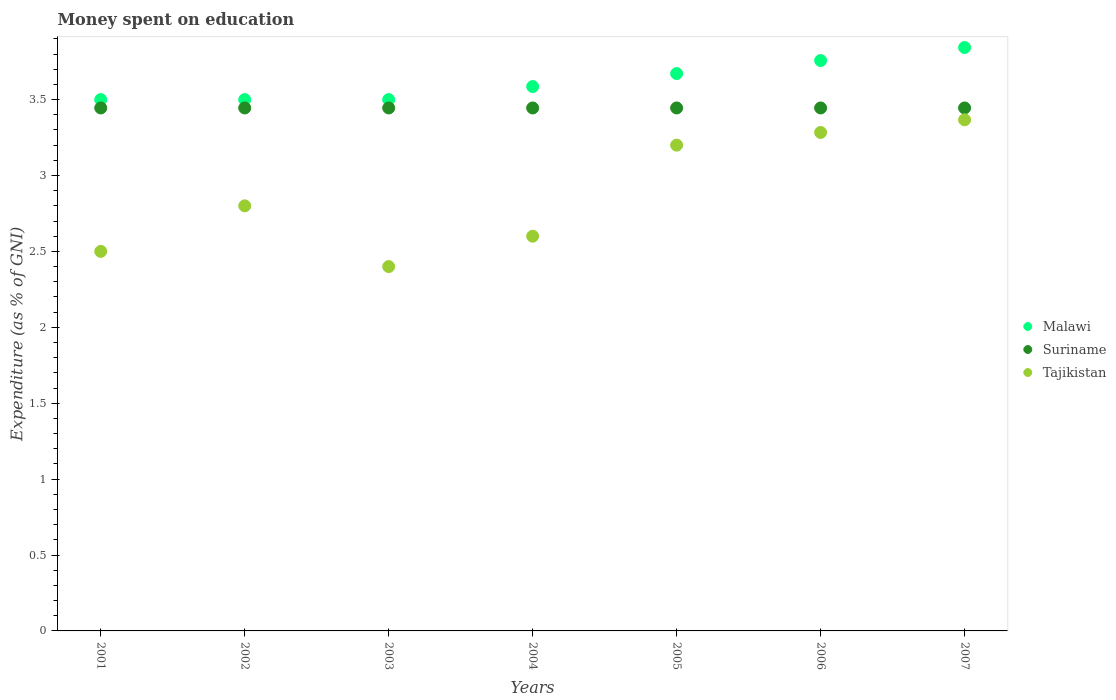How many different coloured dotlines are there?
Keep it short and to the point. 3. Is the number of dotlines equal to the number of legend labels?
Provide a short and direct response. Yes. Across all years, what is the maximum amount of money spent on education in Tajikistan?
Offer a terse response. 3.37. In which year was the amount of money spent on education in Suriname maximum?
Your answer should be very brief. 2001. What is the total amount of money spent on education in Suriname in the graph?
Your response must be concise. 24.11. What is the difference between the amount of money spent on education in Tajikistan in 2002 and that in 2004?
Keep it short and to the point. 0.2. What is the difference between the amount of money spent on education in Malawi in 2001 and the amount of money spent on education in Suriname in 2007?
Provide a succinct answer. 0.06. What is the average amount of money spent on education in Malawi per year?
Ensure brevity in your answer.  3.62. In the year 2005, what is the difference between the amount of money spent on education in Malawi and amount of money spent on education in Suriname?
Offer a very short reply. 0.23. In how many years, is the amount of money spent on education in Suriname greater than 3.1 %?
Offer a very short reply. 7. What is the ratio of the amount of money spent on education in Suriname in 2003 to that in 2004?
Your response must be concise. 1. What is the difference between the highest and the second highest amount of money spent on education in Malawi?
Ensure brevity in your answer.  0.09. Is the sum of the amount of money spent on education in Suriname in 2001 and 2003 greater than the maximum amount of money spent on education in Malawi across all years?
Give a very brief answer. Yes. Is it the case that in every year, the sum of the amount of money spent on education in Tajikistan and amount of money spent on education in Suriname  is greater than the amount of money spent on education in Malawi?
Ensure brevity in your answer.  Yes. Does the amount of money spent on education in Suriname monotonically increase over the years?
Your answer should be very brief. No. Is the amount of money spent on education in Suriname strictly greater than the amount of money spent on education in Malawi over the years?
Offer a very short reply. No. Is the amount of money spent on education in Malawi strictly less than the amount of money spent on education in Suriname over the years?
Make the answer very short. No. How many dotlines are there?
Give a very brief answer. 3. Does the graph contain any zero values?
Your answer should be very brief. No. Where does the legend appear in the graph?
Make the answer very short. Center right. How are the legend labels stacked?
Give a very brief answer. Vertical. What is the title of the graph?
Give a very brief answer. Money spent on education. Does "Mauritius" appear as one of the legend labels in the graph?
Offer a terse response. No. What is the label or title of the Y-axis?
Your answer should be compact. Expenditure (as % of GNI). What is the Expenditure (as % of GNI) in Suriname in 2001?
Your answer should be very brief. 3.44. What is the Expenditure (as % of GNI) of Tajikistan in 2001?
Make the answer very short. 2.5. What is the Expenditure (as % of GNI) of Suriname in 2002?
Keep it short and to the point. 3.44. What is the Expenditure (as % of GNI) in Malawi in 2003?
Offer a terse response. 3.5. What is the Expenditure (as % of GNI) of Suriname in 2003?
Provide a short and direct response. 3.44. What is the Expenditure (as % of GNI) of Tajikistan in 2003?
Ensure brevity in your answer.  2.4. What is the Expenditure (as % of GNI) in Malawi in 2004?
Your answer should be compact. 3.59. What is the Expenditure (as % of GNI) of Suriname in 2004?
Provide a succinct answer. 3.44. What is the Expenditure (as % of GNI) of Malawi in 2005?
Your answer should be very brief. 3.67. What is the Expenditure (as % of GNI) of Suriname in 2005?
Your answer should be compact. 3.44. What is the Expenditure (as % of GNI) of Tajikistan in 2005?
Your response must be concise. 3.2. What is the Expenditure (as % of GNI) of Malawi in 2006?
Give a very brief answer. 3.76. What is the Expenditure (as % of GNI) in Suriname in 2006?
Offer a very short reply. 3.44. What is the Expenditure (as % of GNI) of Tajikistan in 2006?
Offer a very short reply. 3.28. What is the Expenditure (as % of GNI) in Malawi in 2007?
Ensure brevity in your answer.  3.84. What is the Expenditure (as % of GNI) of Suriname in 2007?
Keep it short and to the point. 3.44. What is the Expenditure (as % of GNI) in Tajikistan in 2007?
Your answer should be compact. 3.37. Across all years, what is the maximum Expenditure (as % of GNI) of Malawi?
Your response must be concise. 3.84. Across all years, what is the maximum Expenditure (as % of GNI) of Suriname?
Provide a short and direct response. 3.44. Across all years, what is the maximum Expenditure (as % of GNI) of Tajikistan?
Make the answer very short. 3.37. Across all years, what is the minimum Expenditure (as % of GNI) in Suriname?
Your answer should be very brief. 3.44. What is the total Expenditure (as % of GNI) of Malawi in the graph?
Your answer should be very brief. 25.36. What is the total Expenditure (as % of GNI) of Suriname in the graph?
Provide a succinct answer. 24.11. What is the total Expenditure (as % of GNI) of Tajikistan in the graph?
Make the answer very short. 20.15. What is the difference between the Expenditure (as % of GNI) of Malawi in 2001 and that in 2002?
Offer a very short reply. 0. What is the difference between the Expenditure (as % of GNI) in Suriname in 2001 and that in 2002?
Provide a succinct answer. 0. What is the difference between the Expenditure (as % of GNI) in Malawi in 2001 and that in 2004?
Offer a terse response. -0.09. What is the difference between the Expenditure (as % of GNI) of Malawi in 2001 and that in 2005?
Provide a succinct answer. -0.17. What is the difference between the Expenditure (as % of GNI) of Suriname in 2001 and that in 2005?
Provide a short and direct response. 0. What is the difference between the Expenditure (as % of GNI) of Malawi in 2001 and that in 2006?
Offer a very short reply. -0.26. What is the difference between the Expenditure (as % of GNI) of Suriname in 2001 and that in 2006?
Provide a short and direct response. 0. What is the difference between the Expenditure (as % of GNI) in Tajikistan in 2001 and that in 2006?
Your answer should be very brief. -0.78. What is the difference between the Expenditure (as % of GNI) in Malawi in 2001 and that in 2007?
Your answer should be very brief. -0.34. What is the difference between the Expenditure (as % of GNI) of Suriname in 2001 and that in 2007?
Offer a terse response. 0. What is the difference between the Expenditure (as % of GNI) of Tajikistan in 2001 and that in 2007?
Ensure brevity in your answer.  -0.87. What is the difference between the Expenditure (as % of GNI) of Malawi in 2002 and that in 2003?
Provide a succinct answer. 0. What is the difference between the Expenditure (as % of GNI) of Suriname in 2002 and that in 2003?
Provide a succinct answer. 0. What is the difference between the Expenditure (as % of GNI) of Tajikistan in 2002 and that in 2003?
Provide a short and direct response. 0.4. What is the difference between the Expenditure (as % of GNI) in Malawi in 2002 and that in 2004?
Give a very brief answer. -0.09. What is the difference between the Expenditure (as % of GNI) in Suriname in 2002 and that in 2004?
Keep it short and to the point. 0. What is the difference between the Expenditure (as % of GNI) of Tajikistan in 2002 and that in 2004?
Offer a terse response. 0.2. What is the difference between the Expenditure (as % of GNI) in Malawi in 2002 and that in 2005?
Offer a terse response. -0.17. What is the difference between the Expenditure (as % of GNI) in Malawi in 2002 and that in 2006?
Ensure brevity in your answer.  -0.26. What is the difference between the Expenditure (as % of GNI) of Tajikistan in 2002 and that in 2006?
Provide a succinct answer. -0.48. What is the difference between the Expenditure (as % of GNI) in Malawi in 2002 and that in 2007?
Your answer should be very brief. -0.34. What is the difference between the Expenditure (as % of GNI) of Tajikistan in 2002 and that in 2007?
Offer a very short reply. -0.57. What is the difference between the Expenditure (as % of GNI) of Malawi in 2003 and that in 2004?
Give a very brief answer. -0.09. What is the difference between the Expenditure (as % of GNI) in Suriname in 2003 and that in 2004?
Give a very brief answer. 0. What is the difference between the Expenditure (as % of GNI) of Tajikistan in 2003 and that in 2004?
Provide a succinct answer. -0.2. What is the difference between the Expenditure (as % of GNI) of Malawi in 2003 and that in 2005?
Your response must be concise. -0.17. What is the difference between the Expenditure (as % of GNI) in Suriname in 2003 and that in 2005?
Give a very brief answer. 0. What is the difference between the Expenditure (as % of GNI) in Tajikistan in 2003 and that in 2005?
Provide a succinct answer. -0.8. What is the difference between the Expenditure (as % of GNI) in Malawi in 2003 and that in 2006?
Offer a very short reply. -0.26. What is the difference between the Expenditure (as % of GNI) of Suriname in 2003 and that in 2006?
Give a very brief answer. 0. What is the difference between the Expenditure (as % of GNI) of Tajikistan in 2003 and that in 2006?
Your answer should be very brief. -0.88. What is the difference between the Expenditure (as % of GNI) in Malawi in 2003 and that in 2007?
Give a very brief answer. -0.34. What is the difference between the Expenditure (as % of GNI) of Suriname in 2003 and that in 2007?
Give a very brief answer. 0. What is the difference between the Expenditure (as % of GNI) of Tajikistan in 2003 and that in 2007?
Offer a terse response. -0.97. What is the difference between the Expenditure (as % of GNI) of Malawi in 2004 and that in 2005?
Provide a short and direct response. -0.09. What is the difference between the Expenditure (as % of GNI) of Suriname in 2004 and that in 2005?
Provide a succinct answer. 0. What is the difference between the Expenditure (as % of GNI) of Malawi in 2004 and that in 2006?
Your response must be concise. -0.17. What is the difference between the Expenditure (as % of GNI) of Tajikistan in 2004 and that in 2006?
Ensure brevity in your answer.  -0.68. What is the difference between the Expenditure (as % of GNI) of Malawi in 2004 and that in 2007?
Give a very brief answer. -0.26. What is the difference between the Expenditure (as % of GNI) in Tajikistan in 2004 and that in 2007?
Your response must be concise. -0.77. What is the difference between the Expenditure (as % of GNI) in Malawi in 2005 and that in 2006?
Provide a short and direct response. -0.09. What is the difference between the Expenditure (as % of GNI) of Tajikistan in 2005 and that in 2006?
Provide a short and direct response. -0.08. What is the difference between the Expenditure (as % of GNI) of Malawi in 2005 and that in 2007?
Offer a very short reply. -0.17. What is the difference between the Expenditure (as % of GNI) in Suriname in 2005 and that in 2007?
Give a very brief answer. 0. What is the difference between the Expenditure (as % of GNI) of Tajikistan in 2005 and that in 2007?
Offer a terse response. -0.17. What is the difference between the Expenditure (as % of GNI) in Malawi in 2006 and that in 2007?
Keep it short and to the point. -0.09. What is the difference between the Expenditure (as % of GNI) of Tajikistan in 2006 and that in 2007?
Offer a very short reply. -0.08. What is the difference between the Expenditure (as % of GNI) in Malawi in 2001 and the Expenditure (as % of GNI) in Suriname in 2002?
Give a very brief answer. 0.06. What is the difference between the Expenditure (as % of GNI) of Suriname in 2001 and the Expenditure (as % of GNI) of Tajikistan in 2002?
Offer a terse response. 0.64. What is the difference between the Expenditure (as % of GNI) of Malawi in 2001 and the Expenditure (as % of GNI) of Suriname in 2003?
Provide a short and direct response. 0.06. What is the difference between the Expenditure (as % of GNI) of Suriname in 2001 and the Expenditure (as % of GNI) of Tajikistan in 2003?
Ensure brevity in your answer.  1.04. What is the difference between the Expenditure (as % of GNI) in Malawi in 2001 and the Expenditure (as % of GNI) in Suriname in 2004?
Offer a very short reply. 0.06. What is the difference between the Expenditure (as % of GNI) of Suriname in 2001 and the Expenditure (as % of GNI) of Tajikistan in 2004?
Keep it short and to the point. 0.84. What is the difference between the Expenditure (as % of GNI) in Malawi in 2001 and the Expenditure (as % of GNI) in Suriname in 2005?
Ensure brevity in your answer.  0.06. What is the difference between the Expenditure (as % of GNI) of Suriname in 2001 and the Expenditure (as % of GNI) of Tajikistan in 2005?
Give a very brief answer. 0.24. What is the difference between the Expenditure (as % of GNI) in Malawi in 2001 and the Expenditure (as % of GNI) in Suriname in 2006?
Offer a terse response. 0.06. What is the difference between the Expenditure (as % of GNI) in Malawi in 2001 and the Expenditure (as % of GNI) in Tajikistan in 2006?
Keep it short and to the point. 0.22. What is the difference between the Expenditure (as % of GNI) in Suriname in 2001 and the Expenditure (as % of GNI) in Tajikistan in 2006?
Offer a very short reply. 0.16. What is the difference between the Expenditure (as % of GNI) in Malawi in 2001 and the Expenditure (as % of GNI) in Suriname in 2007?
Provide a short and direct response. 0.06. What is the difference between the Expenditure (as % of GNI) of Malawi in 2001 and the Expenditure (as % of GNI) of Tajikistan in 2007?
Make the answer very short. 0.13. What is the difference between the Expenditure (as % of GNI) of Suriname in 2001 and the Expenditure (as % of GNI) of Tajikistan in 2007?
Your response must be concise. 0.08. What is the difference between the Expenditure (as % of GNI) of Malawi in 2002 and the Expenditure (as % of GNI) of Suriname in 2003?
Your answer should be very brief. 0.06. What is the difference between the Expenditure (as % of GNI) in Malawi in 2002 and the Expenditure (as % of GNI) in Tajikistan in 2003?
Give a very brief answer. 1.1. What is the difference between the Expenditure (as % of GNI) of Suriname in 2002 and the Expenditure (as % of GNI) of Tajikistan in 2003?
Make the answer very short. 1.04. What is the difference between the Expenditure (as % of GNI) of Malawi in 2002 and the Expenditure (as % of GNI) of Suriname in 2004?
Make the answer very short. 0.06. What is the difference between the Expenditure (as % of GNI) in Malawi in 2002 and the Expenditure (as % of GNI) in Tajikistan in 2004?
Give a very brief answer. 0.9. What is the difference between the Expenditure (as % of GNI) of Suriname in 2002 and the Expenditure (as % of GNI) of Tajikistan in 2004?
Make the answer very short. 0.84. What is the difference between the Expenditure (as % of GNI) in Malawi in 2002 and the Expenditure (as % of GNI) in Suriname in 2005?
Your response must be concise. 0.06. What is the difference between the Expenditure (as % of GNI) in Malawi in 2002 and the Expenditure (as % of GNI) in Tajikistan in 2005?
Offer a very short reply. 0.3. What is the difference between the Expenditure (as % of GNI) in Suriname in 2002 and the Expenditure (as % of GNI) in Tajikistan in 2005?
Your answer should be compact. 0.24. What is the difference between the Expenditure (as % of GNI) of Malawi in 2002 and the Expenditure (as % of GNI) of Suriname in 2006?
Make the answer very short. 0.06. What is the difference between the Expenditure (as % of GNI) of Malawi in 2002 and the Expenditure (as % of GNI) of Tajikistan in 2006?
Provide a succinct answer. 0.22. What is the difference between the Expenditure (as % of GNI) of Suriname in 2002 and the Expenditure (as % of GNI) of Tajikistan in 2006?
Offer a very short reply. 0.16. What is the difference between the Expenditure (as % of GNI) of Malawi in 2002 and the Expenditure (as % of GNI) of Suriname in 2007?
Make the answer very short. 0.06. What is the difference between the Expenditure (as % of GNI) in Malawi in 2002 and the Expenditure (as % of GNI) in Tajikistan in 2007?
Offer a very short reply. 0.13. What is the difference between the Expenditure (as % of GNI) of Suriname in 2002 and the Expenditure (as % of GNI) of Tajikistan in 2007?
Offer a very short reply. 0.08. What is the difference between the Expenditure (as % of GNI) of Malawi in 2003 and the Expenditure (as % of GNI) of Suriname in 2004?
Your response must be concise. 0.06. What is the difference between the Expenditure (as % of GNI) of Suriname in 2003 and the Expenditure (as % of GNI) of Tajikistan in 2004?
Keep it short and to the point. 0.84. What is the difference between the Expenditure (as % of GNI) of Malawi in 2003 and the Expenditure (as % of GNI) of Suriname in 2005?
Your answer should be compact. 0.06. What is the difference between the Expenditure (as % of GNI) in Malawi in 2003 and the Expenditure (as % of GNI) in Tajikistan in 2005?
Make the answer very short. 0.3. What is the difference between the Expenditure (as % of GNI) in Suriname in 2003 and the Expenditure (as % of GNI) in Tajikistan in 2005?
Give a very brief answer. 0.24. What is the difference between the Expenditure (as % of GNI) of Malawi in 2003 and the Expenditure (as % of GNI) of Suriname in 2006?
Your answer should be very brief. 0.06. What is the difference between the Expenditure (as % of GNI) of Malawi in 2003 and the Expenditure (as % of GNI) of Tajikistan in 2006?
Offer a terse response. 0.22. What is the difference between the Expenditure (as % of GNI) of Suriname in 2003 and the Expenditure (as % of GNI) of Tajikistan in 2006?
Make the answer very short. 0.16. What is the difference between the Expenditure (as % of GNI) of Malawi in 2003 and the Expenditure (as % of GNI) of Suriname in 2007?
Keep it short and to the point. 0.06. What is the difference between the Expenditure (as % of GNI) in Malawi in 2003 and the Expenditure (as % of GNI) in Tajikistan in 2007?
Provide a succinct answer. 0.13. What is the difference between the Expenditure (as % of GNI) in Suriname in 2003 and the Expenditure (as % of GNI) in Tajikistan in 2007?
Give a very brief answer. 0.08. What is the difference between the Expenditure (as % of GNI) in Malawi in 2004 and the Expenditure (as % of GNI) in Suriname in 2005?
Provide a short and direct response. 0.14. What is the difference between the Expenditure (as % of GNI) of Malawi in 2004 and the Expenditure (as % of GNI) of Tajikistan in 2005?
Provide a short and direct response. 0.39. What is the difference between the Expenditure (as % of GNI) of Suriname in 2004 and the Expenditure (as % of GNI) of Tajikistan in 2005?
Provide a succinct answer. 0.24. What is the difference between the Expenditure (as % of GNI) of Malawi in 2004 and the Expenditure (as % of GNI) of Suriname in 2006?
Your answer should be compact. 0.14. What is the difference between the Expenditure (as % of GNI) in Malawi in 2004 and the Expenditure (as % of GNI) in Tajikistan in 2006?
Offer a terse response. 0.3. What is the difference between the Expenditure (as % of GNI) of Suriname in 2004 and the Expenditure (as % of GNI) of Tajikistan in 2006?
Make the answer very short. 0.16. What is the difference between the Expenditure (as % of GNI) in Malawi in 2004 and the Expenditure (as % of GNI) in Suriname in 2007?
Your response must be concise. 0.14. What is the difference between the Expenditure (as % of GNI) in Malawi in 2004 and the Expenditure (as % of GNI) in Tajikistan in 2007?
Provide a short and direct response. 0.22. What is the difference between the Expenditure (as % of GNI) in Suriname in 2004 and the Expenditure (as % of GNI) in Tajikistan in 2007?
Offer a very short reply. 0.08. What is the difference between the Expenditure (as % of GNI) of Malawi in 2005 and the Expenditure (as % of GNI) of Suriname in 2006?
Offer a very short reply. 0.23. What is the difference between the Expenditure (as % of GNI) of Malawi in 2005 and the Expenditure (as % of GNI) of Tajikistan in 2006?
Offer a very short reply. 0.39. What is the difference between the Expenditure (as % of GNI) in Suriname in 2005 and the Expenditure (as % of GNI) in Tajikistan in 2006?
Your answer should be very brief. 0.16. What is the difference between the Expenditure (as % of GNI) in Malawi in 2005 and the Expenditure (as % of GNI) in Suriname in 2007?
Your response must be concise. 0.23. What is the difference between the Expenditure (as % of GNI) in Malawi in 2005 and the Expenditure (as % of GNI) in Tajikistan in 2007?
Provide a succinct answer. 0.3. What is the difference between the Expenditure (as % of GNI) of Suriname in 2005 and the Expenditure (as % of GNI) of Tajikistan in 2007?
Offer a terse response. 0.08. What is the difference between the Expenditure (as % of GNI) in Malawi in 2006 and the Expenditure (as % of GNI) in Suriname in 2007?
Offer a very short reply. 0.31. What is the difference between the Expenditure (as % of GNI) in Malawi in 2006 and the Expenditure (as % of GNI) in Tajikistan in 2007?
Your answer should be very brief. 0.39. What is the difference between the Expenditure (as % of GNI) in Suriname in 2006 and the Expenditure (as % of GNI) in Tajikistan in 2007?
Provide a short and direct response. 0.08. What is the average Expenditure (as % of GNI) of Malawi per year?
Ensure brevity in your answer.  3.62. What is the average Expenditure (as % of GNI) in Suriname per year?
Offer a terse response. 3.44. What is the average Expenditure (as % of GNI) in Tajikistan per year?
Ensure brevity in your answer.  2.88. In the year 2001, what is the difference between the Expenditure (as % of GNI) in Malawi and Expenditure (as % of GNI) in Suriname?
Provide a short and direct response. 0.06. In the year 2001, what is the difference between the Expenditure (as % of GNI) in Suriname and Expenditure (as % of GNI) in Tajikistan?
Your answer should be very brief. 0.94. In the year 2002, what is the difference between the Expenditure (as % of GNI) of Malawi and Expenditure (as % of GNI) of Suriname?
Your response must be concise. 0.06. In the year 2002, what is the difference between the Expenditure (as % of GNI) of Malawi and Expenditure (as % of GNI) of Tajikistan?
Your answer should be compact. 0.7. In the year 2002, what is the difference between the Expenditure (as % of GNI) of Suriname and Expenditure (as % of GNI) of Tajikistan?
Make the answer very short. 0.64. In the year 2003, what is the difference between the Expenditure (as % of GNI) of Malawi and Expenditure (as % of GNI) of Suriname?
Keep it short and to the point. 0.06. In the year 2003, what is the difference between the Expenditure (as % of GNI) of Suriname and Expenditure (as % of GNI) of Tajikistan?
Offer a very short reply. 1.04. In the year 2004, what is the difference between the Expenditure (as % of GNI) of Malawi and Expenditure (as % of GNI) of Suriname?
Make the answer very short. 0.14. In the year 2004, what is the difference between the Expenditure (as % of GNI) of Malawi and Expenditure (as % of GNI) of Tajikistan?
Provide a short and direct response. 0.99. In the year 2004, what is the difference between the Expenditure (as % of GNI) of Suriname and Expenditure (as % of GNI) of Tajikistan?
Provide a succinct answer. 0.84. In the year 2005, what is the difference between the Expenditure (as % of GNI) in Malawi and Expenditure (as % of GNI) in Suriname?
Your answer should be very brief. 0.23. In the year 2005, what is the difference between the Expenditure (as % of GNI) of Malawi and Expenditure (as % of GNI) of Tajikistan?
Ensure brevity in your answer.  0.47. In the year 2005, what is the difference between the Expenditure (as % of GNI) in Suriname and Expenditure (as % of GNI) in Tajikistan?
Provide a succinct answer. 0.24. In the year 2006, what is the difference between the Expenditure (as % of GNI) in Malawi and Expenditure (as % of GNI) in Suriname?
Provide a succinct answer. 0.31. In the year 2006, what is the difference between the Expenditure (as % of GNI) of Malawi and Expenditure (as % of GNI) of Tajikistan?
Provide a succinct answer. 0.47. In the year 2006, what is the difference between the Expenditure (as % of GNI) of Suriname and Expenditure (as % of GNI) of Tajikistan?
Your answer should be very brief. 0.16. In the year 2007, what is the difference between the Expenditure (as % of GNI) of Malawi and Expenditure (as % of GNI) of Suriname?
Ensure brevity in your answer.  0.4. In the year 2007, what is the difference between the Expenditure (as % of GNI) in Malawi and Expenditure (as % of GNI) in Tajikistan?
Ensure brevity in your answer.  0.48. In the year 2007, what is the difference between the Expenditure (as % of GNI) in Suriname and Expenditure (as % of GNI) in Tajikistan?
Provide a short and direct response. 0.08. What is the ratio of the Expenditure (as % of GNI) of Malawi in 2001 to that in 2002?
Give a very brief answer. 1. What is the ratio of the Expenditure (as % of GNI) in Tajikistan in 2001 to that in 2002?
Offer a very short reply. 0.89. What is the ratio of the Expenditure (as % of GNI) in Tajikistan in 2001 to that in 2003?
Your response must be concise. 1.04. What is the ratio of the Expenditure (as % of GNI) in Malawi in 2001 to that in 2004?
Keep it short and to the point. 0.98. What is the ratio of the Expenditure (as % of GNI) in Suriname in 2001 to that in 2004?
Offer a terse response. 1. What is the ratio of the Expenditure (as % of GNI) of Tajikistan in 2001 to that in 2004?
Offer a terse response. 0.96. What is the ratio of the Expenditure (as % of GNI) of Malawi in 2001 to that in 2005?
Keep it short and to the point. 0.95. What is the ratio of the Expenditure (as % of GNI) in Suriname in 2001 to that in 2005?
Provide a short and direct response. 1. What is the ratio of the Expenditure (as % of GNI) in Tajikistan in 2001 to that in 2005?
Provide a succinct answer. 0.78. What is the ratio of the Expenditure (as % of GNI) of Malawi in 2001 to that in 2006?
Make the answer very short. 0.93. What is the ratio of the Expenditure (as % of GNI) of Suriname in 2001 to that in 2006?
Keep it short and to the point. 1. What is the ratio of the Expenditure (as % of GNI) in Tajikistan in 2001 to that in 2006?
Your answer should be compact. 0.76. What is the ratio of the Expenditure (as % of GNI) of Malawi in 2001 to that in 2007?
Your response must be concise. 0.91. What is the ratio of the Expenditure (as % of GNI) of Tajikistan in 2001 to that in 2007?
Your answer should be very brief. 0.74. What is the ratio of the Expenditure (as % of GNI) of Malawi in 2002 to that in 2003?
Offer a very short reply. 1. What is the ratio of the Expenditure (as % of GNI) in Malawi in 2002 to that in 2004?
Keep it short and to the point. 0.98. What is the ratio of the Expenditure (as % of GNI) in Suriname in 2002 to that in 2004?
Your answer should be compact. 1. What is the ratio of the Expenditure (as % of GNI) of Malawi in 2002 to that in 2005?
Ensure brevity in your answer.  0.95. What is the ratio of the Expenditure (as % of GNI) of Malawi in 2002 to that in 2006?
Keep it short and to the point. 0.93. What is the ratio of the Expenditure (as % of GNI) in Suriname in 2002 to that in 2006?
Keep it short and to the point. 1. What is the ratio of the Expenditure (as % of GNI) of Tajikistan in 2002 to that in 2006?
Ensure brevity in your answer.  0.85. What is the ratio of the Expenditure (as % of GNI) of Malawi in 2002 to that in 2007?
Give a very brief answer. 0.91. What is the ratio of the Expenditure (as % of GNI) of Tajikistan in 2002 to that in 2007?
Provide a succinct answer. 0.83. What is the ratio of the Expenditure (as % of GNI) of Malawi in 2003 to that in 2004?
Offer a terse response. 0.98. What is the ratio of the Expenditure (as % of GNI) of Tajikistan in 2003 to that in 2004?
Ensure brevity in your answer.  0.92. What is the ratio of the Expenditure (as % of GNI) in Malawi in 2003 to that in 2005?
Provide a succinct answer. 0.95. What is the ratio of the Expenditure (as % of GNI) in Suriname in 2003 to that in 2005?
Give a very brief answer. 1. What is the ratio of the Expenditure (as % of GNI) in Tajikistan in 2003 to that in 2005?
Ensure brevity in your answer.  0.75. What is the ratio of the Expenditure (as % of GNI) of Malawi in 2003 to that in 2006?
Provide a short and direct response. 0.93. What is the ratio of the Expenditure (as % of GNI) in Suriname in 2003 to that in 2006?
Give a very brief answer. 1. What is the ratio of the Expenditure (as % of GNI) in Tajikistan in 2003 to that in 2006?
Ensure brevity in your answer.  0.73. What is the ratio of the Expenditure (as % of GNI) of Malawi in 2003 to that in 2007?
Your answer should be very brief. 0.91. What is the ratio of the Expenditure (as % of GNI) of Suriname in 2003 to that in 2007?
Give a very brief answer. 1. What is the ratio of the Expenditure (as % of GNI) of Tajikistan in 2003 to that in 2007?
Your answer should be compact. 0.71. What is the ratio of the Expenditure (as % of GNI) of Malawi in 2004 to that in 2005?
Ensure brevity in your answer.  0.98. What is the ratio of the Expenditure (as % of GNI) of Tajikistan in 2004 to that in 2005?
Give a very brief answer. 0.81. What is the ratio of the Expenditure (as % of GNI) in Malawi in 2004 to that in 2006?
Give a very brief answer. 0.95. What is the ratio of the Expenditure (as % of GNI) of Suriname in 2004 to that in 2006?
Your answer should be compact. 1. What is the ratio of the Expenditure (as % of GNI) in Tajikistan in 2004 to that in 2006?
Ensure brevity in your answer.  0.79. What is the ratio of the Expenditure (as % of GNI) in Malawi in 2004 to that in 2007?
Make the answer very short. 0.93. What is the ratio of the Expenditure (as % of GNI) of Suriname in 2004 to that in 2007?
Ensure brevity in your answer.  1. What is the ratio of the Expenditure (as % of GNI) in Tajikistan in 2004 to that in 2007?
Make the answer very short. 0.77. What is the ratio of the Expenditure (as % of GNI) in Malawi in 2005 to that in 2006?
Your answer should be very brief. 0.98. What is the ratio of the Expenditure (as % of GNI) of Suriname in 2005 to that in 2006?
Provide a succinct answer. 1. What is the ratio of the Expenditure (as % of GNI) in Tajikistan in 2005 to that in 2006?
Provide a succinct answer. 0.97. What is the ratio of the Expenditure (as % of GNI) in Malawi in 2005 to that in 2007?
Ensure brevity in your answer.  0.96. What is the ratio of the Expenditure (as % of GNI) in Tajikistan in 2005 to that in 2007?
Your answer should be compact. 0.95. What is the ratio of the Expenditure (as % of GNI) in Malawi in 2006 to that in 2007?
Provide a succinct answer. 0.98. What is the ratio of the Expenditure (as % of GNI) in Suriname in 2006 to that in 2007?
Provide a succinct answer. 1. What is the ratio of the Expenditure (as % of GNI) of Tajikistan in 2006 to that in 2007?
Your response must be concise. 0.98. What is the difference between the highest and the second highest Expenditure (as % of GNI) in Malawi?
Ensure brevity in your answer.  0.09. What is the difference between the highest and the second highest Expenditure (as % of GNI) of Tajikistan?
Offer a terse response. 0.08. What is the difference between the highest and the lowest Expenditure (as % of GNI) of Malawi?
Keep it short and to the point. 0.34. What is the difference between the highest and the lowest Expenditure (as % of GNI) in Suriname?
Your answer should be very brief. 0. What is the difference between the highest and the lowest Expenditure (as % of GNI) of Tajikistan?
Your response must be concise. 0.97. 